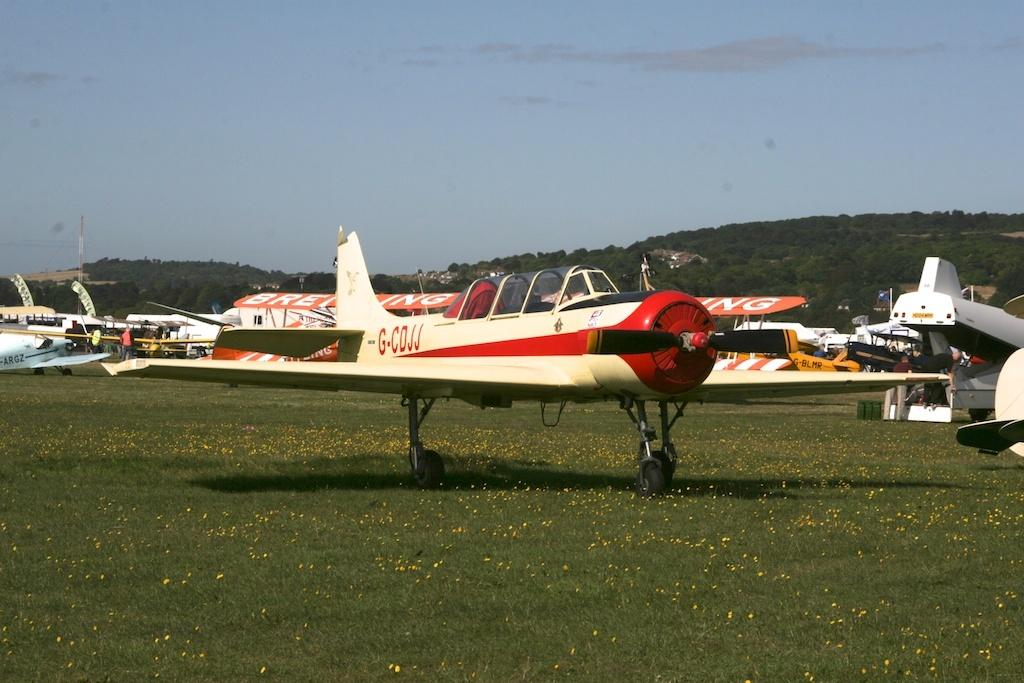What is the main subject of the image? The main subject of the image is planes. Where are the planes located? The planes are on the grass. What can be seen in the background of the image? There are hills visible in the background of the image. How many beds can be seen in the image? There are no beds present in the image. What type of exchange is taking place between the planes in the image? There is no exchange taking place between the planes in the image; they are simply on the grass. 